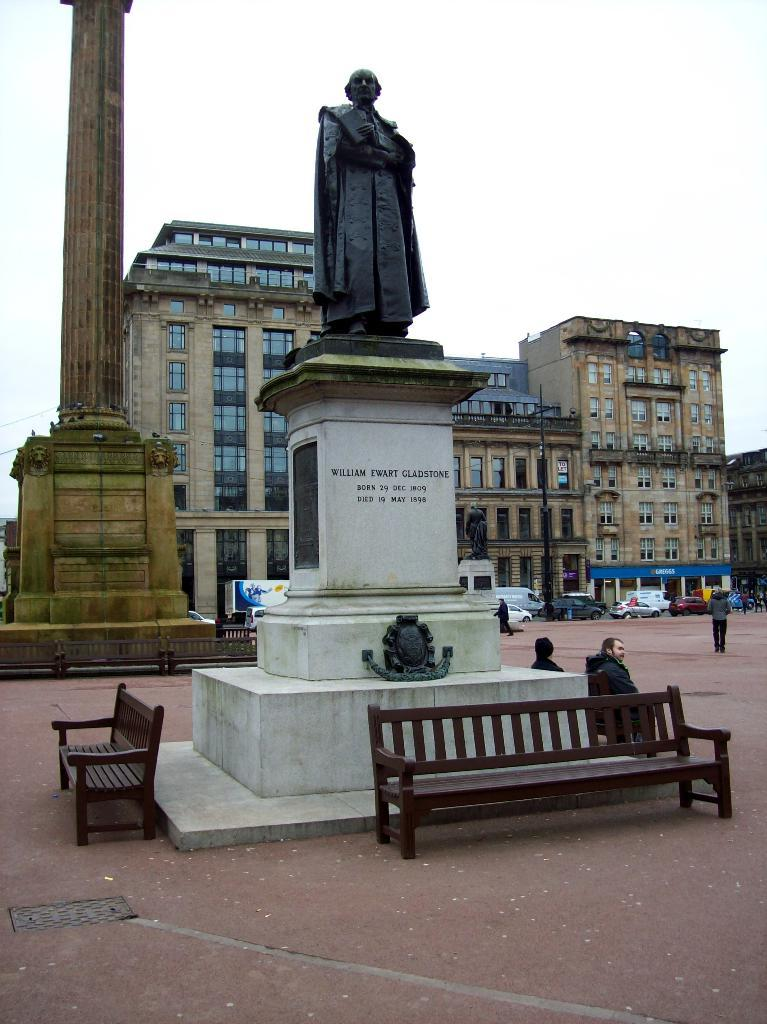What is the main subject in the image? There is a person standing in the image. What type of structures can be seen in the background? There are buildings in the image. What piece of furniture is present in the image? There is a bench in the image. What else can be seen in the image besides the person, buildings, and bench? There are vehicles in the image. Can you hear the whistle of the snails in the image? There are no snails or whistles present in the image. 